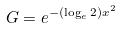<formula> <loc_0><loc_0><loc_500><loc_500>G = e ^ { - ( \log _ { e } 2 ) x ^ { 2 } }</formula> 